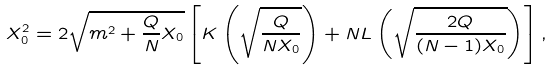<formula> <loc_0><loc_0><loc_500><loc_500>X _ { 0 } ^ { 2 } = 2 \sqrt { m ^ { 2 } + \frac { Q } { N } X _ { 0 } } \left [ K \left ( \sqrt { \frac { Q } { N X _ { 0 } } } \right ) + N L \left ( \sqrt { \frac { 2 Q } { ( N - 1 ) X _ { 0 } } } \right ) \right ] ,</formula> 